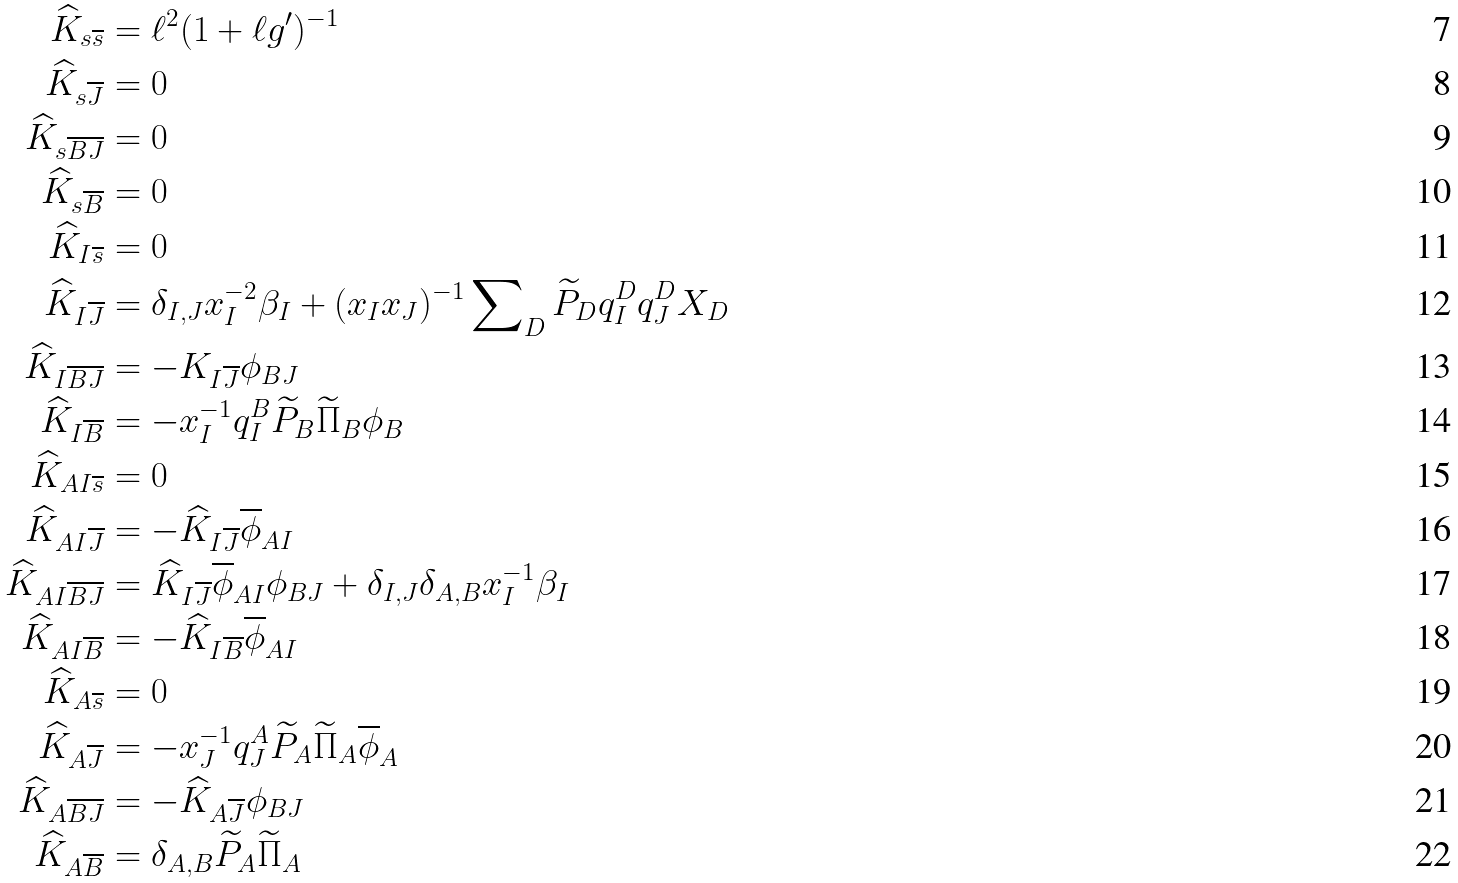Convert formula to latex. <formula><loc_0><loc_0><loc_500><loc_500>\widehat { K } _ { s \overline { s } } & = \ell ^ { 2 } ( 1 + \ell g ^ { \prime } ) ^ { - 1 } \\ \widehat { K } _ { s \overline { J } } & = 0 \\ \widehat { K } _ { s \overline { B J } } & = 0 \\ \widehat { K } _ { s \overline { B } } & = 0 \\ \widehat { K } _ { I \overline { s } } & = 0 \\ \widehat { K } _ { I \overline { J } } & = \delta _ { I , J } x _ { I } ^ { - 2 } \beta _ { I } + ( x _ { I } x _ { J } ) ^ { - 1 } \sum \nolimits _ { D } \widetilde { P } _ { D } q _ { I } ^ { D } q _ { J } ^ { D } X _ { D } \\ \widehat { K } _ { I \overline { B J } } & = - K _ { I \overline { J } } \phi _ { B J } \\ \widehat { K } _ { I \overline { B } } & = - x _ { I } ^ { - 1 } q _ { I } ^ { B } \widetilde { P } _ { B } \widetilde { \Pi } _ { B } \phi _ { B } \\ \widehat { K } _ { A I \overline { s } } & = 0 \\ \widehat { K } _ { A I \overline { J } } & = - \widehat { K } _ { I \overline { J } } \overline { \phi } _ { A I } \\ \widehat { K } _ { A I \overline { B J } } & = \widehat { K } _ { I \overline { J } } \overline { \phi } _ { A I } \phi _ { B J } + \delta _ { I , J } \delta _ { A , B } x _ { I } ^ { - 1 } \beta _ { I } \\ \widehat { K } _ { A I \overline { B } } & = - \widehat { K } _ { I \overline { B } } \overline { \phi } _ { A I } \\ \widehat { K } _ { A \overline { s } } & = 0 \\ \widehat { K } _ { A \overline { J } } & = - x _ { J } ^ { - 1 } q _ { J } ^ { A } \widetilde { P } _ { A } \widetilde { \Pi } _ { A } \overline { \phi } _ { A } \\ \widehat { K } _ { A \overline { B J } } & = - \widehat { K } _ { A \overline { J } } \phi _ { B J } \\ \widehat { K } _ { A \overline { B } } & = \delta _ { A , B } \widetilde { P } _ { A } \widetilde { \Pi } _ { A }</formula> 